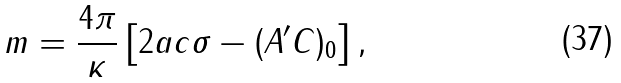<formula> <loc_0><loc_0><loc_500><loc_500>m = \frac { 4 \pi } { \kappa } \left [ 2 a c \sigma - ( A ^ { \prime } C ) _ { 0 } \right ] ,</formula> 